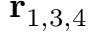<formula> <loc_0><loc_0><loc_500><loc_500>r _ { 1 , 3 , 4 }</formula> 